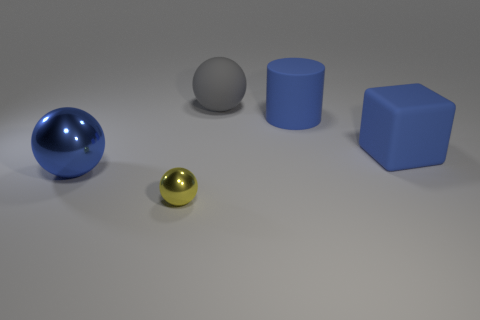Add 2 big cylinders. How many objects exist? 7 Subtract all spheres. How many objects are left? 2 Add 2 large blue matte cylinders. How many large blue matte cylinders exist? 3 Subtract 0 cyan spheres. How many objects are left? 5 Subtract all large blocks. Subtract all large blue matte cylinders. How many objects are left? 3 Add 5 blue things. How many blue things are left? 8 